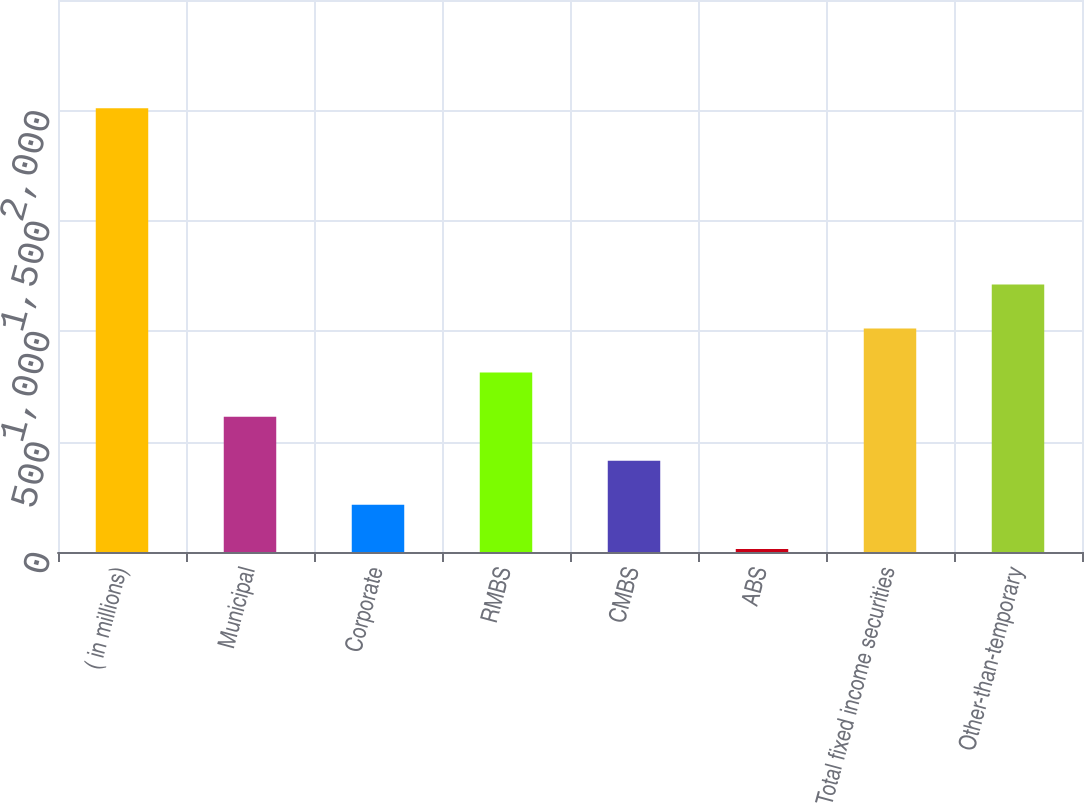Convert chart to OTSL. <chart><loc_0><loc_0><loc_500><loc_500><bar_chart><fcel>( in millions)<fcel>Municipal<fcel>Corporate<fcel>RMBS<fcel>CMBS<fcel>ABS<fcel>Total fixed income securities<fcel>Other-than-temporary<nl><fcel>2010<fcel>612.8<fcel>213.6<fcel>812.4<fcel>413.2<fcel>14<fcel>1012<fcel>1211.6<nl></chart> 